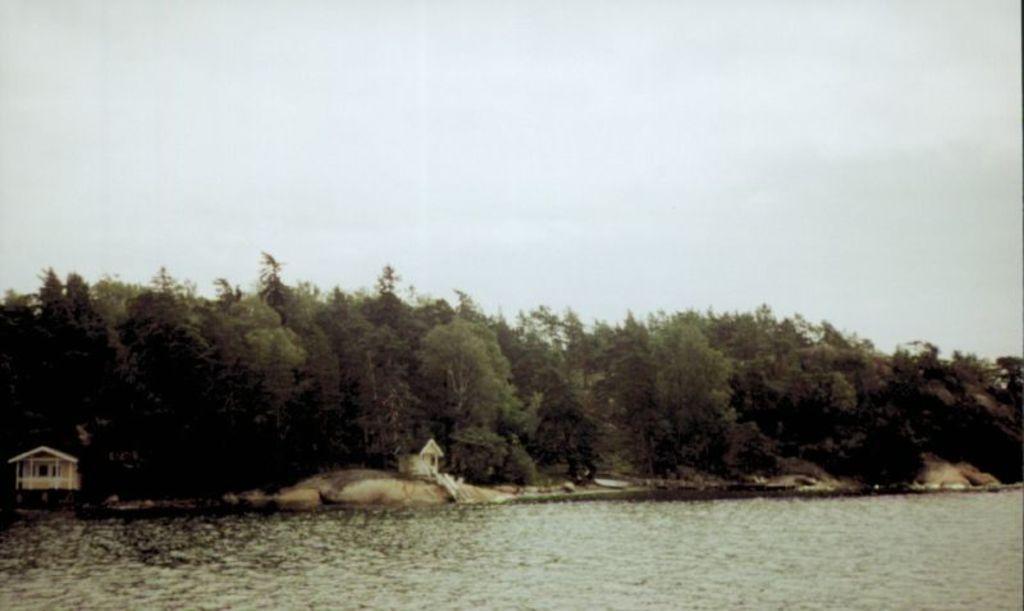Can you describe this image briefly? At the bottom we can see water. There are houses on the ground. In the background there are trees and clouds in the sky. 